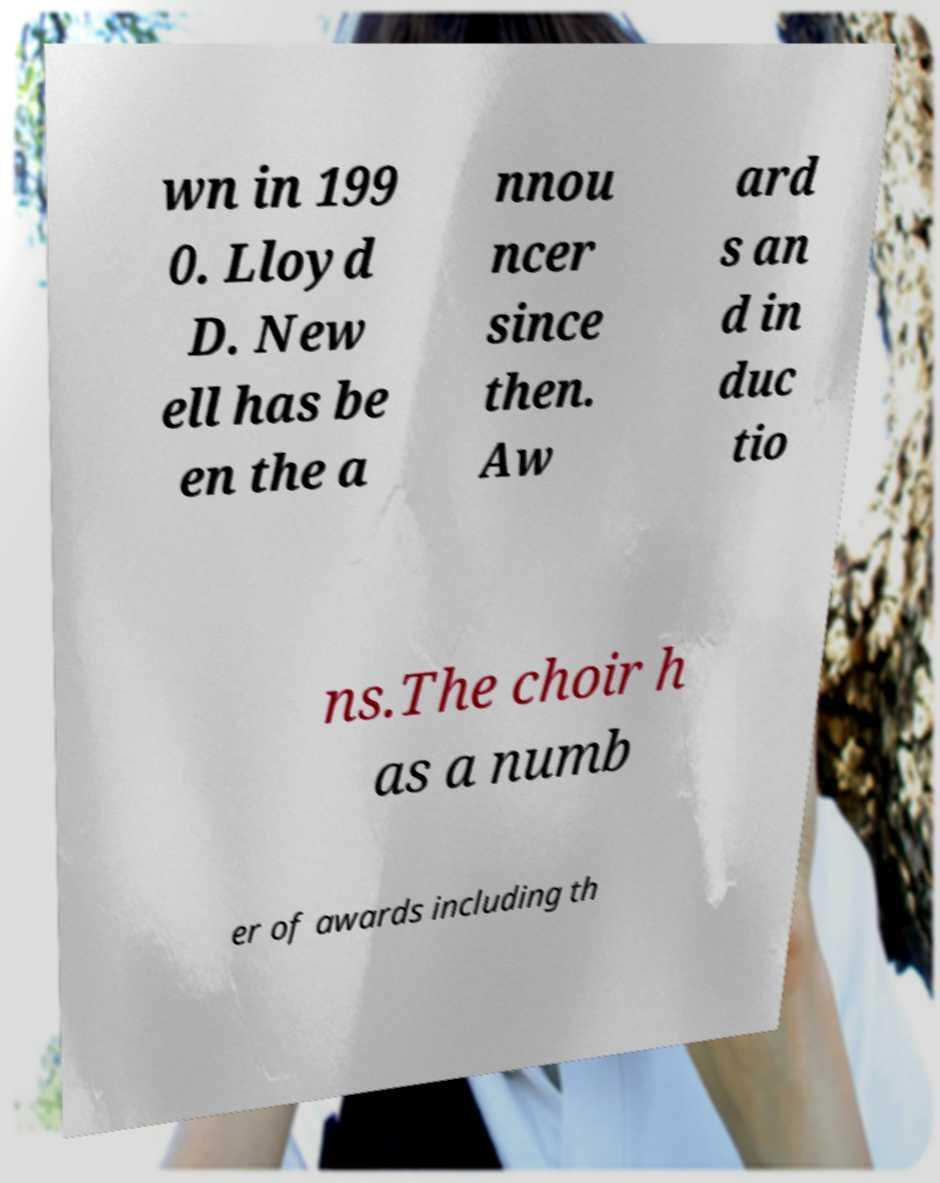For documentation purposes, I need the text within this image transcribed. Could you provide that? wn in 199 0. Lloyd D. New ell has be en the a nnou ncer since then. Aw ard s an d in duc tio ns.The choir h as a numb er of awards including th 